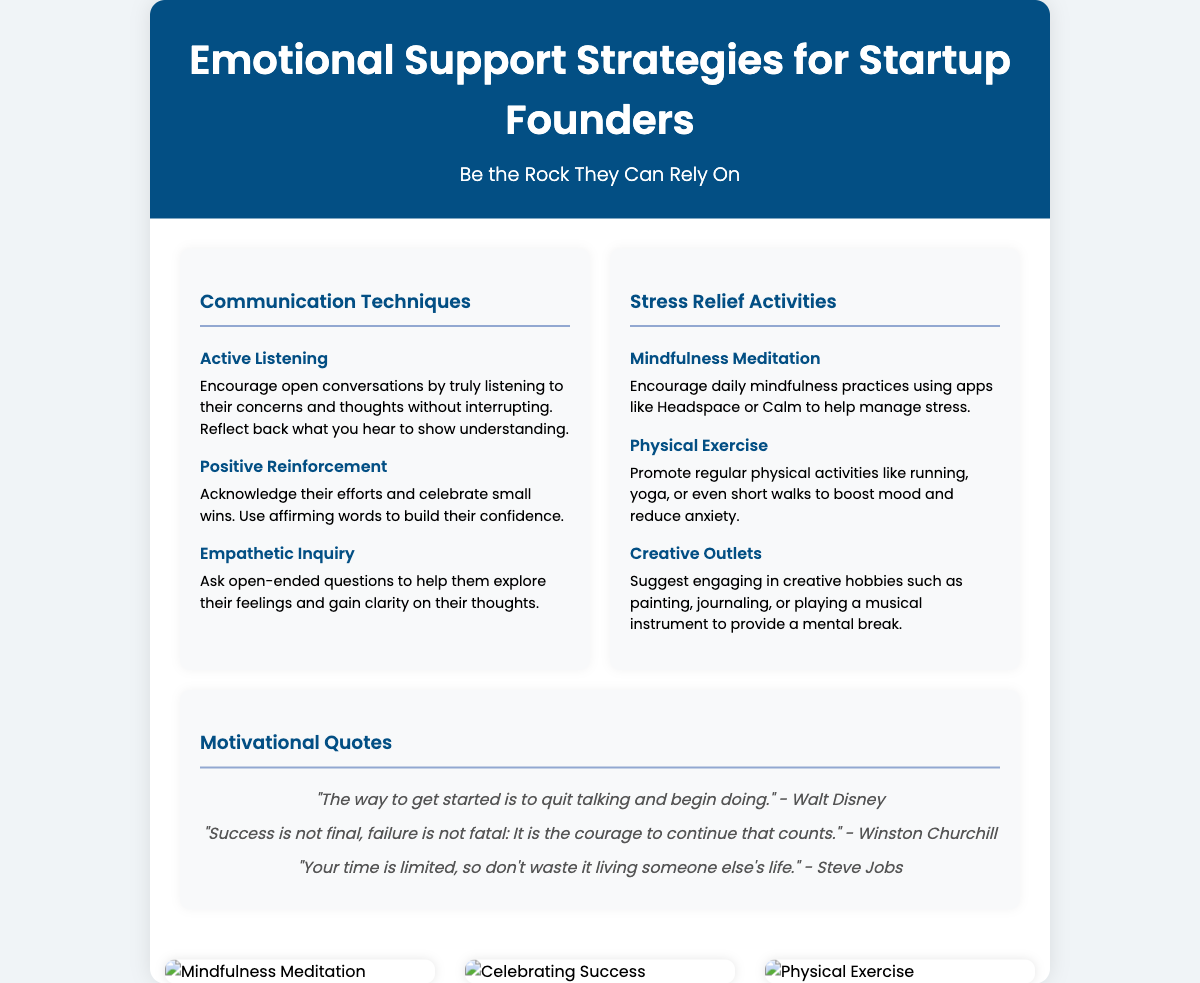What are the three sections of the poster? The poster is divided into three distinct sections, each focusing on a different aspect of emotional support strategies: Communication Techniques, Stress Relief Activities, and Motivational Quotes.
Answer: Communication Techniques, Stress Relief Activities, Motivational Quotes What is one example of a stress relief activity mentioned? One specific stress relief activity is Mindfulness Meditation, which encourages daily mindfulness practices to help manage stress.
Answer: Mindfulness Meditation Who is quoted in the motivational quotes section regarding success and failure? The quote about success and failure is from Winston Churchill, emphasizing that success is not final and failure is not fatal.
Answer: Winston Churchill What communication technique involves asking open-ended questions? The technique that involves asking open-ended questions for exploration of feelings is called Empathetic Inquiry.
Answer: Empathetic Inquiry How many motivational quotes are featured in the document? There are three motivational quotes presented in the poster under the Motivational Quotes section.
Answer: Three 